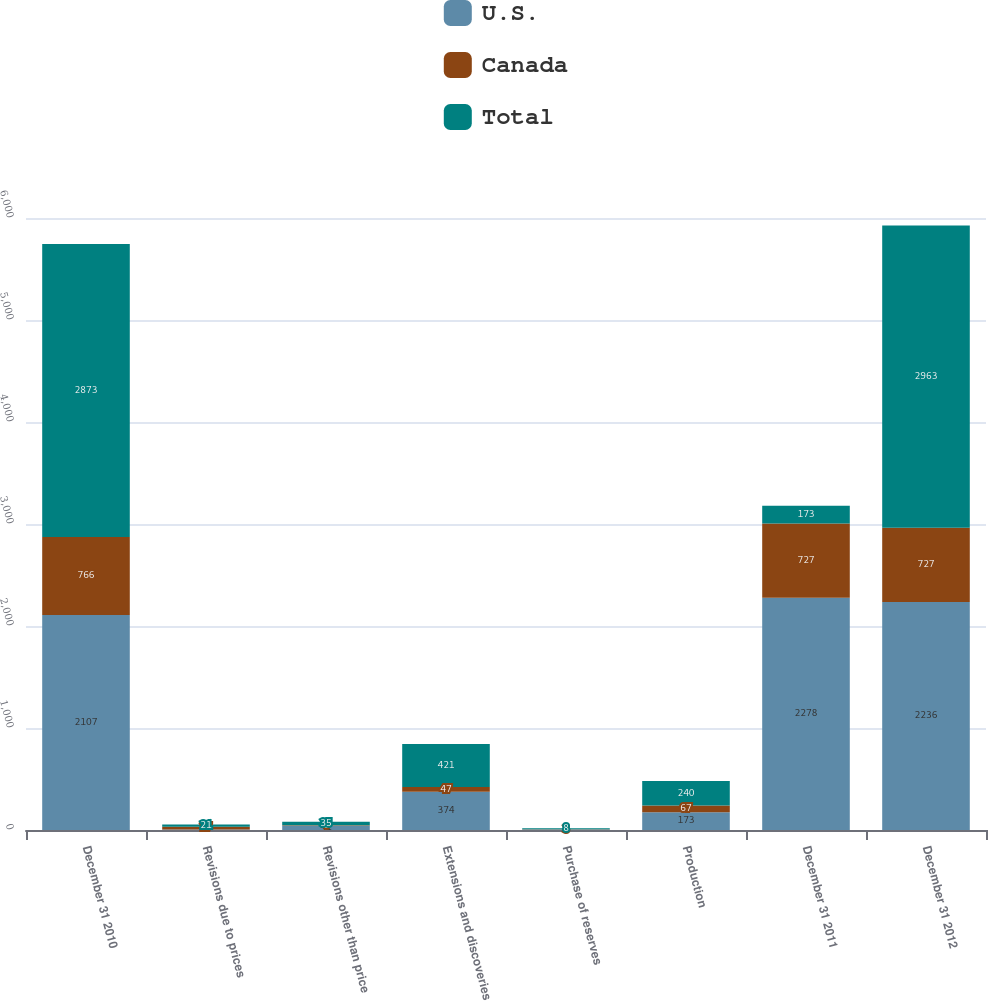Convert chart. <chart><loc_0><loc_0><loc_500><loc_500><stacked_bar_chart><ecel><fcel>December 31 2010<fcel>Revisions due to prices<fcel>Revisions other than price<fcel>Extensions and discoveries<fcel>Purchase of reserves<fcel>Production<fcel>December 31 2011<fcel>December 31 2012<nl><fcel>U.S.<fcel>2107<fcel>6<fcel>41<fcel>374<fcel>5<fcel>173<fcel>2278<fcel>2236<nl><fcel>Canada<fcel>766<fcel>27<fcel>6<fcel>47<fcel>3<fcel>67<fcel>727<fcel>727<nl><fcel>Total<fcel>2873<fcel>21<fcel>35<fcel>421<fcel>8<fcel>240<fcel>173<fcel>2963<nl></chart> 